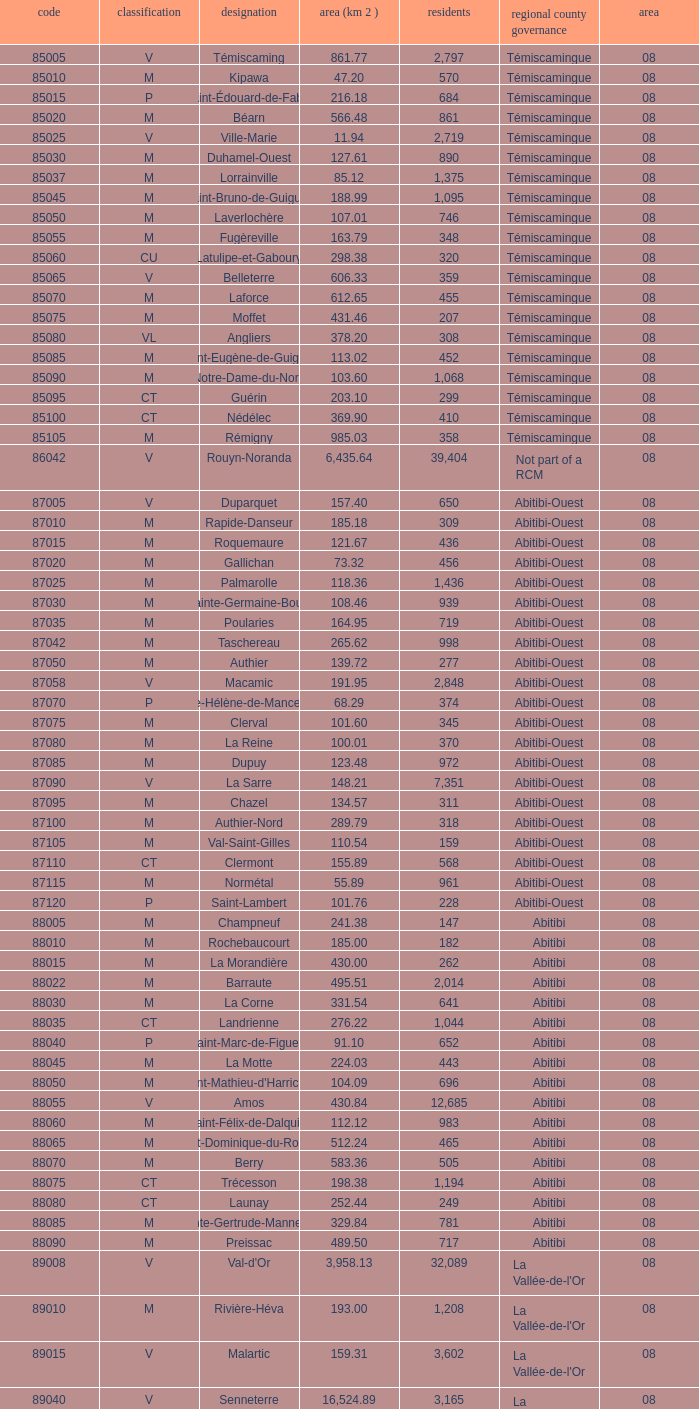What is the km2 area for the population of 311? 134.57. 